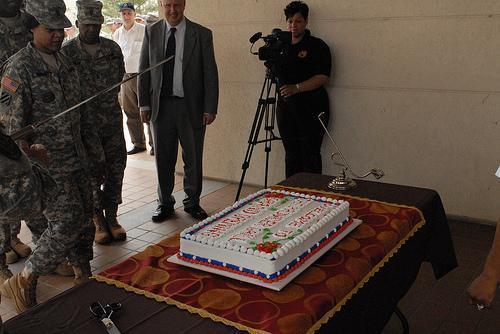How many cakes are there?
Give a very brief answer. 1. 